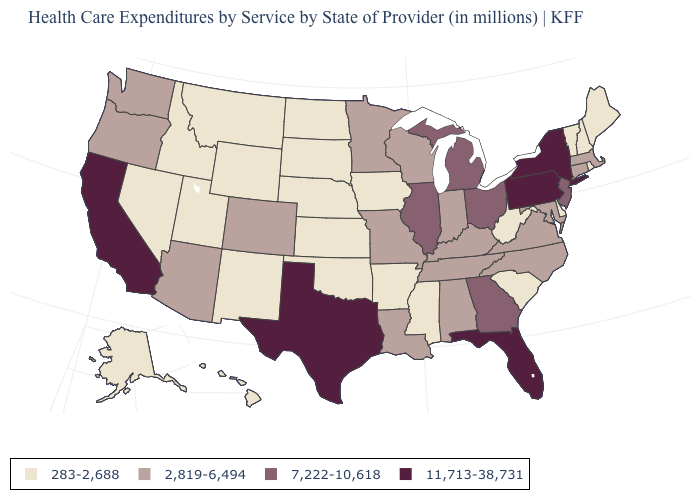Name the states that have a value in the range 2,819-6,494?
Give a very brief answer. Alabama, Arizona, Colorado, Connecticut, Indiana, Kentucky, Louisiana, Maryland, Massachusetts, Minnesota, Missouri, North Carolina, Oregon, Tennessee, Virginia, Washington, Wisconsin. Name the states that have a value in the range 283-2,688?
Short answer required. Alaska, Arkansas, Delaware, Hawaii, Idaho, Iowa, Kansas, Maine, Mississippi, Montana, Nebraska, Nevada, New Hampshire, New Mexico, North Dakota, Oklahoma, Rhode Island, South Carolina, South Dakota, Utah, Vermont, West Virginia, Wyoming. What is the value of Nevada?
Give a very brief answer. 283-2,688. What is the value of Kentucky?
Write a very short answer. 2,819-6,494. Does Oklahoma have the lowest value in the South?
Write a very short answer. Yes. Name the states that have a value in the range 2,819-6,494?
Answer briefly. Alabama, Arizona, Colorado, Connecticut, Indiana, Kentucky, Louisiana, Maryland, Massachusetts, Minnesota, Missouri, North Carolina, Oregon, Tennessee, Virginia, Washington, Wisconsin. Among the states that border Nevada , which have the lowest value?
Give a very brief answer. Idaho, Utah. Does New York have the highest value in the Northeast?
Write a very short answer. Yes. How many symbols are there in the legend?
Answer briefly. 4. What is the lowest value in states that border Georgia?
Concise answer only. 283-2,688. What is the value of New York?
Write a very short answer. 11,713-38,731. What is the value of Nevada?
Be succinct. 283-2,688. Among the states that border Alabama , does Florida have the highest value?
Quick response, please. Yes. Which states have the lowest value in the USA?
Answer briefly. Alaska, Arkansas, Delaware, Hawaii, Idaho, Iowa, Kansas, Maine, Mississippi, Montana, Nebraska, Nevada, New Hampshire, New Mexico, North Dakota, Oklahoma, Rhode Island, South Carolina, South Dakota, Utah, Vermont, West Virginia, Wyoming. What is the lowest value in states that border Tennessee?
Quick response, please. 283-2,688. 